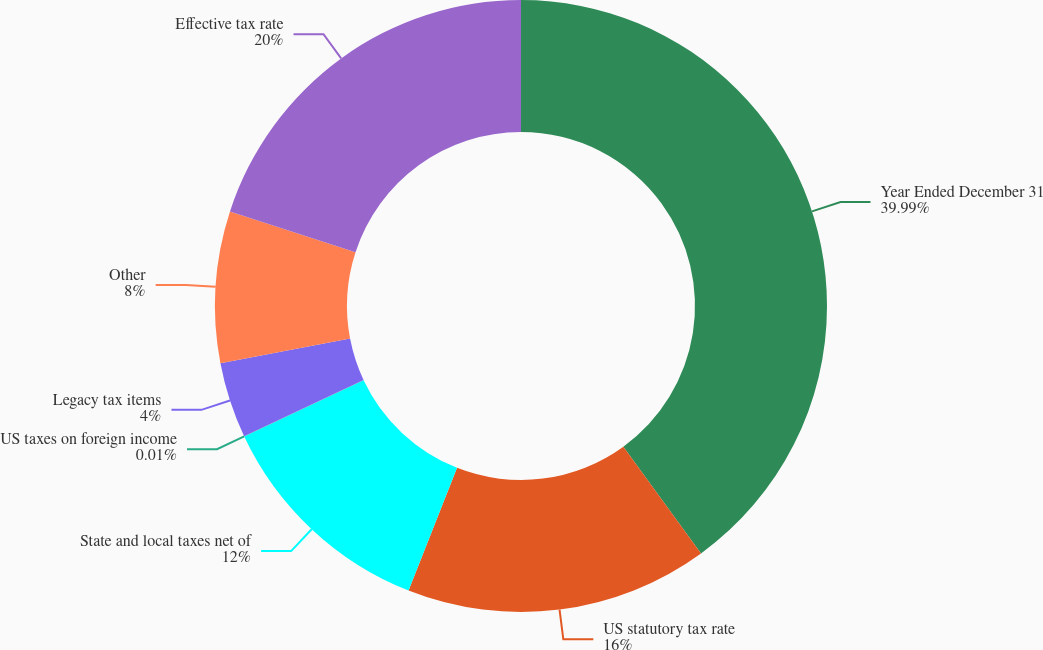Convert chart to OTSL. <chart><loc_0><loc_0><loc_500><loc_500><pie_chart><fcel>Year Ended December 31<fcel>US statutory tax rate<fcel>State and local taxes net of<fcel>US taxes on foreign income<fcel>Legacy tax items<fcel>Other<fcel>Effective tax rate<nl><fcel>39.99%<fcel>16.0%<fcel>12.0%<fcel>0.01%<fcel>4.0%<fcel>8.0%<fcel>20.0%<nl></chart> 